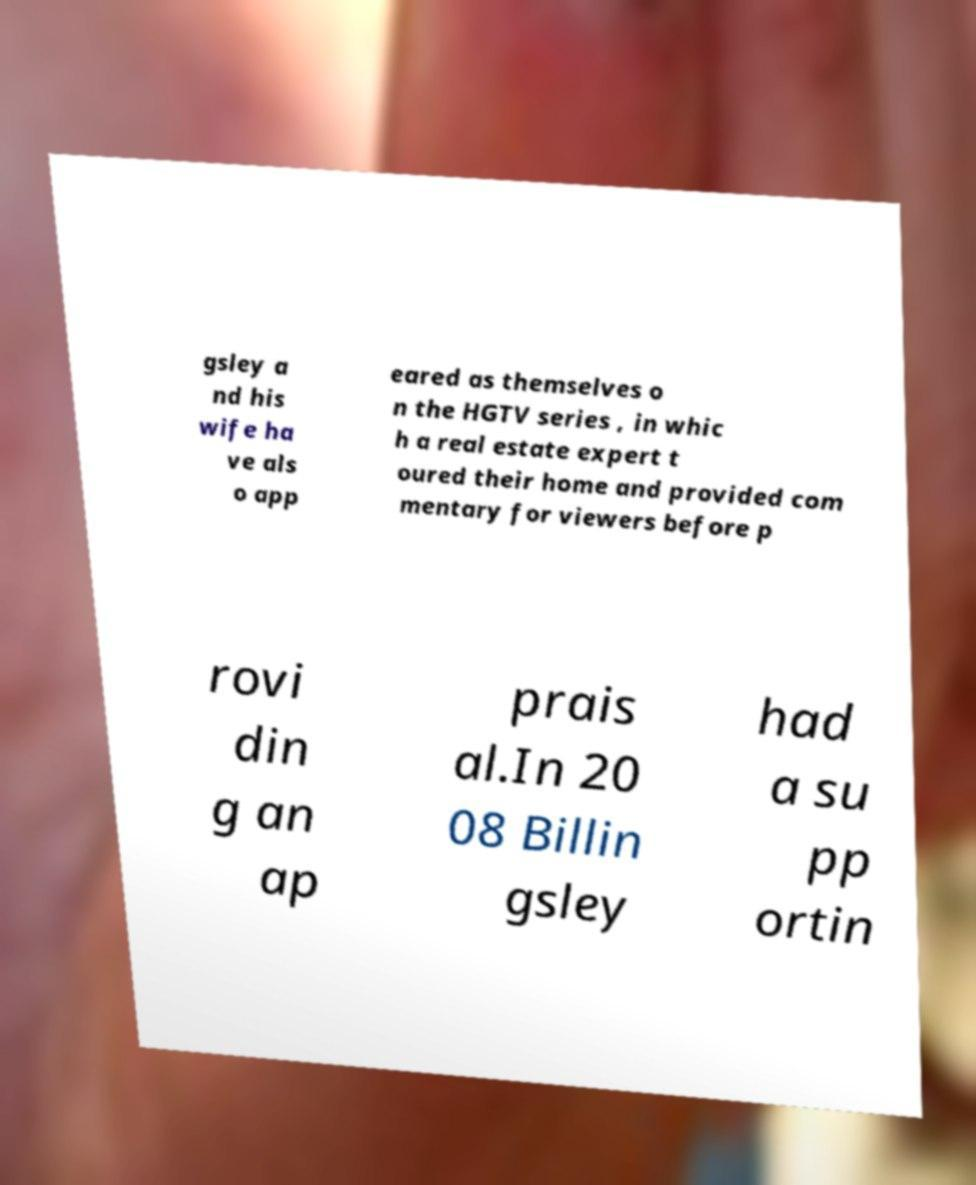There's text embedded in this image that I need extracted. Can you transcribe it verbatim? gsley a nd his wife ha ve als o app eared as themselves o n the HGTV series , in whic h a real estate expert t oured their home and provided com mentary for viewers before p rovi din g an ap prais al.In 20 08 Billin gsley had a su pp ortin 